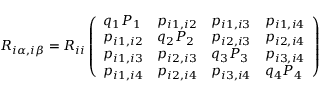Convert formula to latex. <formula><loc_0><loc_0><loc_500><loc_500>R _ { i \alpha , i \beta } = R _ { i i } \left ( \begin{array} { l l l l } { q _ { 1 } P _ { 1 } } & { p _ { i 1 , i 2 } } & { p _ { i 1 , i 3 } } & { p _ { i 1 , i 4 } } \\ { p _ { i 1 , i 2 } } & { q _ { 2 } P _ { 2 } } & { p _ { i 2 , i 3 } } & { p _ { i 2 , i 4 } } \\ { p _ { i 1 , i 3 } } & { p _ { i 2 , i 3 } } & { q _ { 3 } P _ { 3 } } & { p _ { i 3 , i 4 } } \\ { p _ { i 1 , i 4 } } & { p _ { i 2 , i 4 } } & { p _ { i 3 , i 4 } } & { q _ { 4 } P _ { 4 } } \end{array} \right )</formula> 